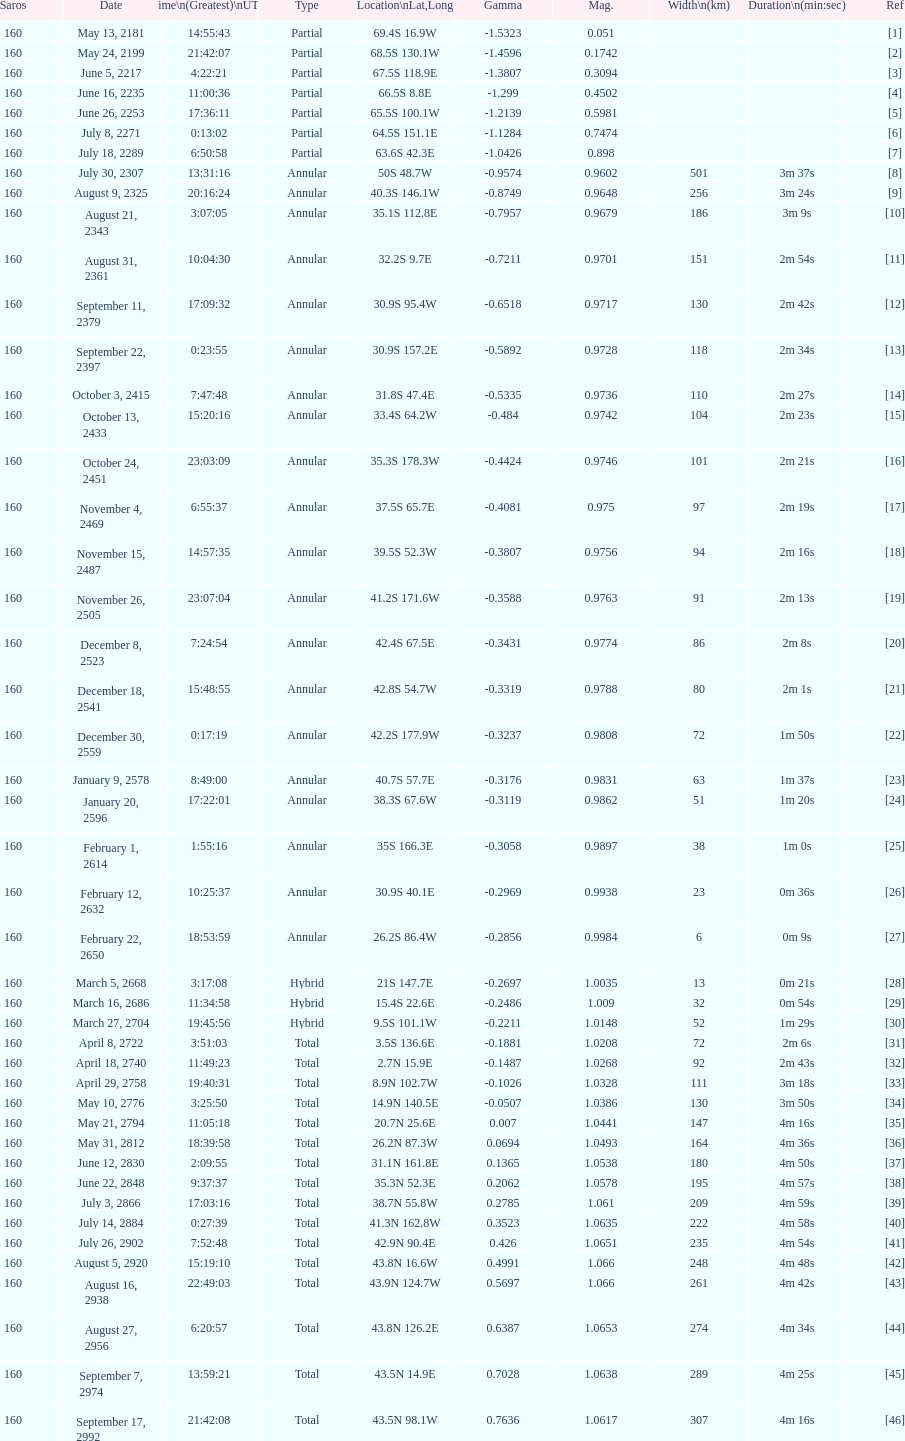When will the next solar saros be after the may 24, 2199 solar saros occurs? June 5, 2217. 